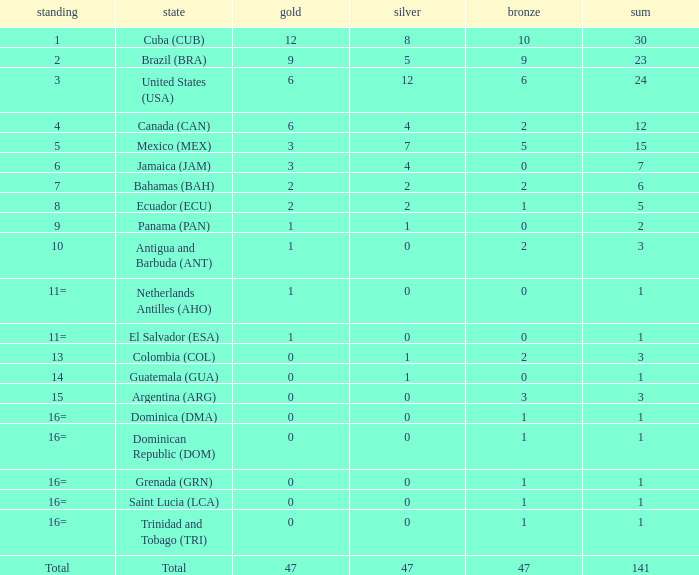Parse the full table. {'header': ['standing', 'state', 'gold', 'silver', 'bronze', 'sum'], 'rows': [['1', 'Cuba (CUB)', '12', '8', '10', '30'], ['2', 'Brazil (BRA)', '9', '5', '9', '23'], ['3', 'United States (USA)', '6', '12', '6', '24'], ['4', 'Canada (CAN)', '6', '4', '2', '12'], ['5', 'Mexico (MEX)', '3', '7', '5', '15'], ['6', 'Jamaica (JAM)', '3', '4', '0', '7'], ['7', 'Bahamas (BAH)', '2', '2', '2', '6'], ['8', 'Ecuador (ECU)', '2', '2', '1', '5'], ['9', 'Panama (PAN)', '1', '1', '0', '2'], ['10', 'Antigua and Barbuda (ANT)', '1', '0', '2', '3'], ['11=', 'Netherlands Antilles (AHO)', '1', '0', '0', '1'], ['11=', 'El Salvador (ESA)', '1', '0', '0', '1'], ['13', 'Colombia (COL)', '0', '1', '2', '3'], ['14', 'Guatemala (GUA)', '0', '1', '0', '1'], ['15', 'Argentina (ARG)', '0', '0', '3', '3'], ['16=', 'Dominica (DMA)', '0', '0', '1', '1'], ['16=', 'Dominican Republic (DOM)', '0', '0', '1', '1'], ['16=', 'Grenada (GRN)', '0', '0', '1', '1'], ['16=', 'Saint Lucia (LCA)', '0', '0', '1', '1'], ['16=', 'Trinidad and Tobago (TRI)', '0', '0', '1', '1'], ['Total', 'Total', '47', '47', '47', '141']]} What is the average silver with more than 0 gold, a Rank of 1, and a Total smaller than 30? None. 